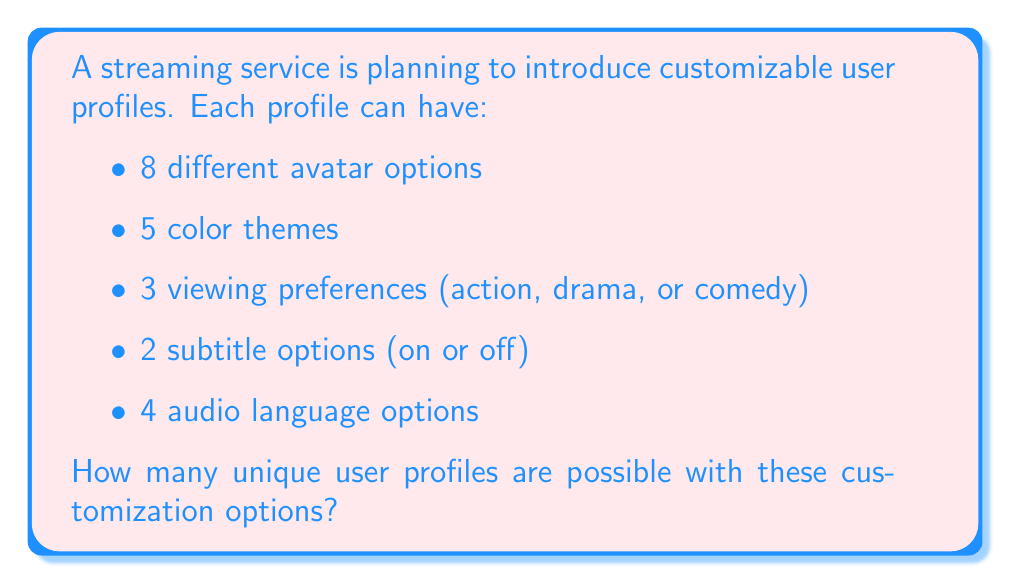Could you help me with this problem? To solve this problem, we'll use the multiplication principle of counting. This principle states that if we have a sequence of independent choices, the total number of possible outcomes is the product of the number of options for each choice.

Let's break down the options:
1. Avatars: 8 choices
2. Color themes: 5 choices
3. Viewing preferences: 3 choices
4. Subtitle options: 2 choices
5. Audio language options: 4 choices

Now, we multiply these numbers together:

$$ 8 \times 5 \times 3 \times 2 \times 4 $$

Calculating this:
$$ 8 \times 5 = 40 $$
$$ 40 \times 3 = 120 $$
$$ 120 \times 2 = 240 $$
$$ 240 \times 4 = 960 $$

Therefore, the total number of unique user profiles possible is 960.
Answer: 960 